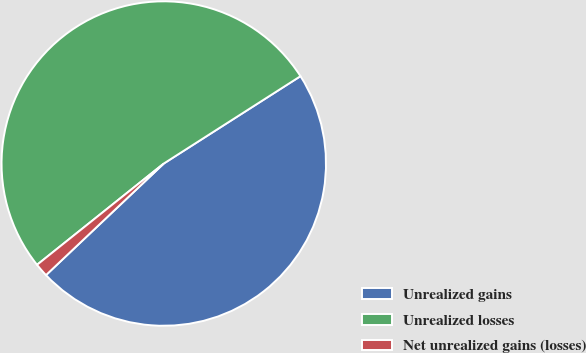Convert chart to OTSL. <chart><loc_0><loc_0><loc_500><loc_500><pie_chart><fcel>Unrealized gains<fcel>Unrealized losses<fcel>Net unrealized gains (losses)<nl><fcel>46.98%<fcel>51.68%<fcel>1.34%<nl></chart> 